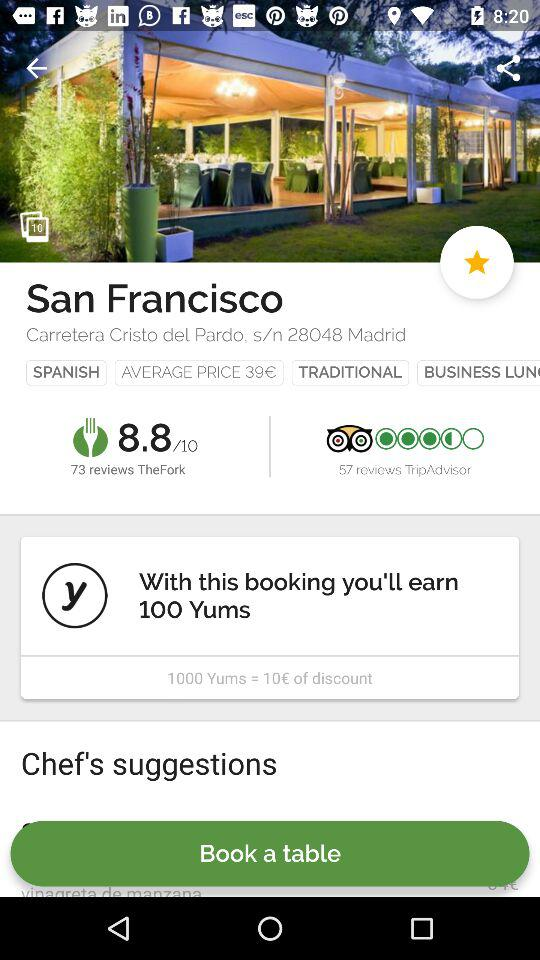What is the location of the hotel? The location is Carretera Cristo del Pardo, s/n 28048 Madrid. 